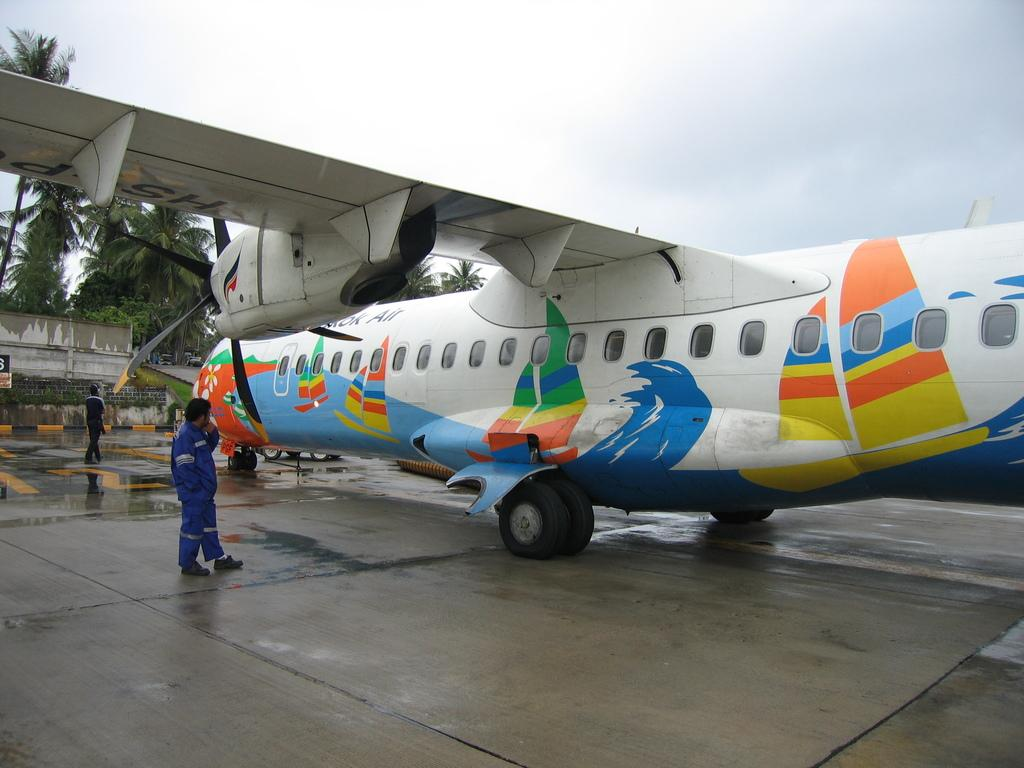What is the main subject of the image? The main subject of the image is a plane on the ground. Can you describe the man's position in the image? The man is standing on the left side of the image. What can be seen on the left side of the image besides the man? There are trees on the left side of the image. What type of chalk is the man using to draw on the plane in the image? There is no chalk or drawing activity present in the image. How many hammers can be seen in the image? There are no hammers visible in the image. 